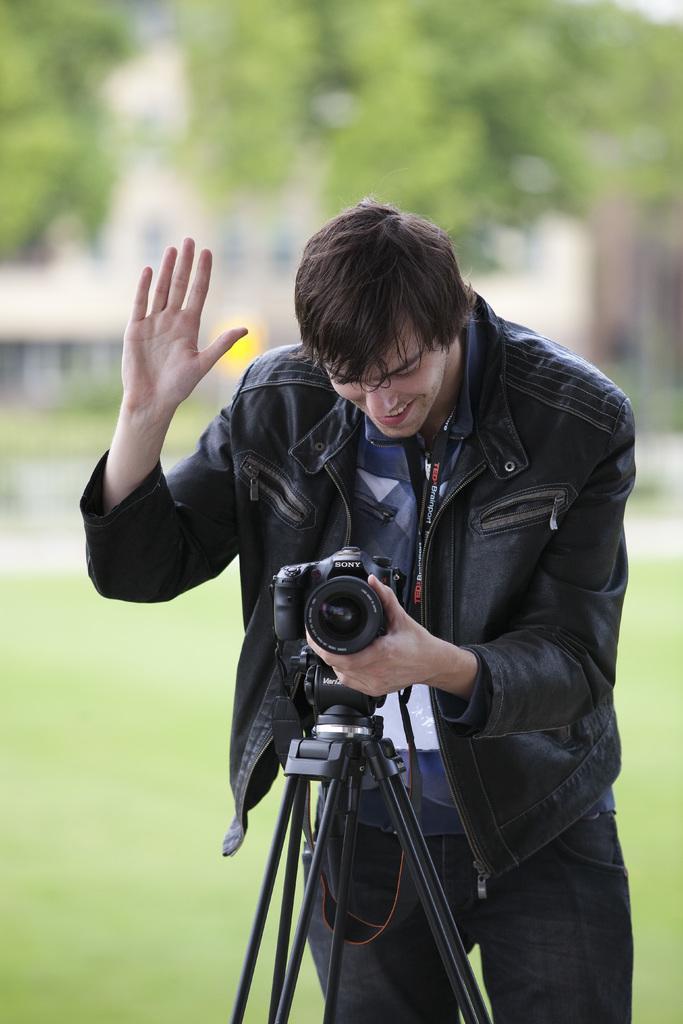How would you summarize this image in a sentence or two? In this image we can see a person holding a camera attached to the stand and a blur background. 